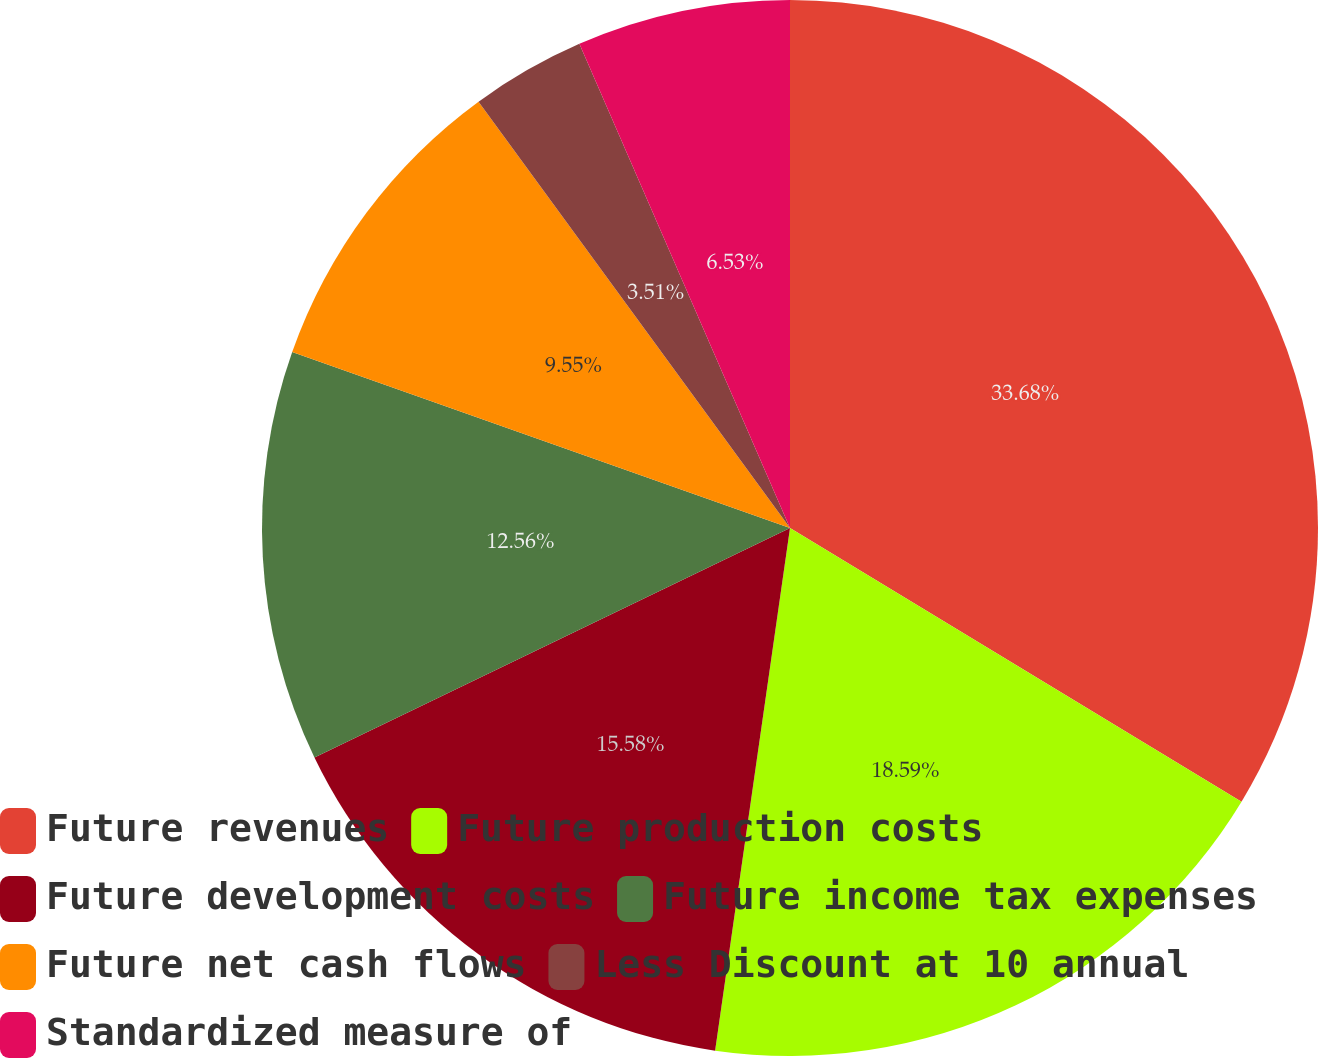Convert chart to OTSL. <chart><loc_0><loc_0><loc_500><loc_500><pie_chart><fcel>Future revenues<fcel>Future production costs<fcel>Future development costs<fcel>Future income tax expenses<fcel>Future net cash flows<fcel>Less Discount at 10 annual<fcel>Standardized measure of<nl><fcel>33.67%<fcel>18.59%<fcel>15.58%<fcel>12.56%<fcel>9.55%<fcel>3.51%<fcel>6.53%<nl></chart> 